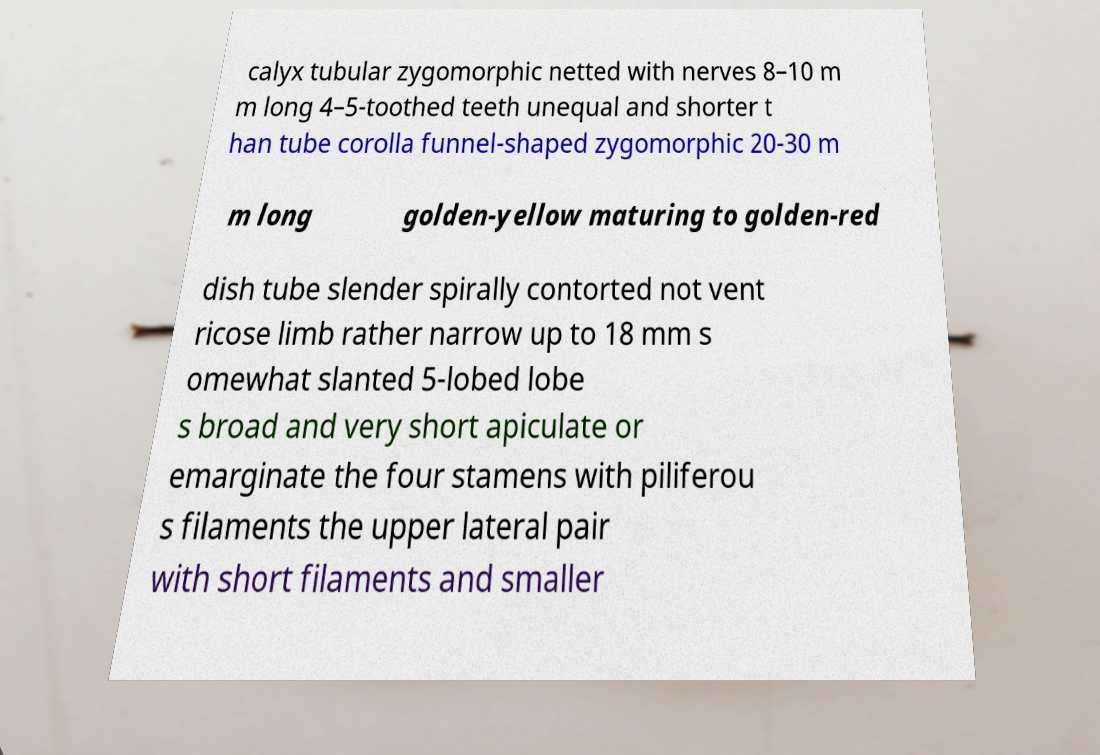Could you assist in decoding the text presented in this image and type it out clearly? calyx tubular zygomorphic netted with nerves 8–10 m m long 4–5-toothed teeth unequal and shorter t han tube corolla funnel-shaped zygomorphic 20-30 m m long golden-yellow maturing to golden-red dish tube slender spirally contorted not vent ricose limb rather narrow up to 18 mm s omewhat slanted 5-lobed lobe s broad and very short apiculate or emarginate the four stamens with piliferou s filaments the upper lateral pair with short filaments and smaller 